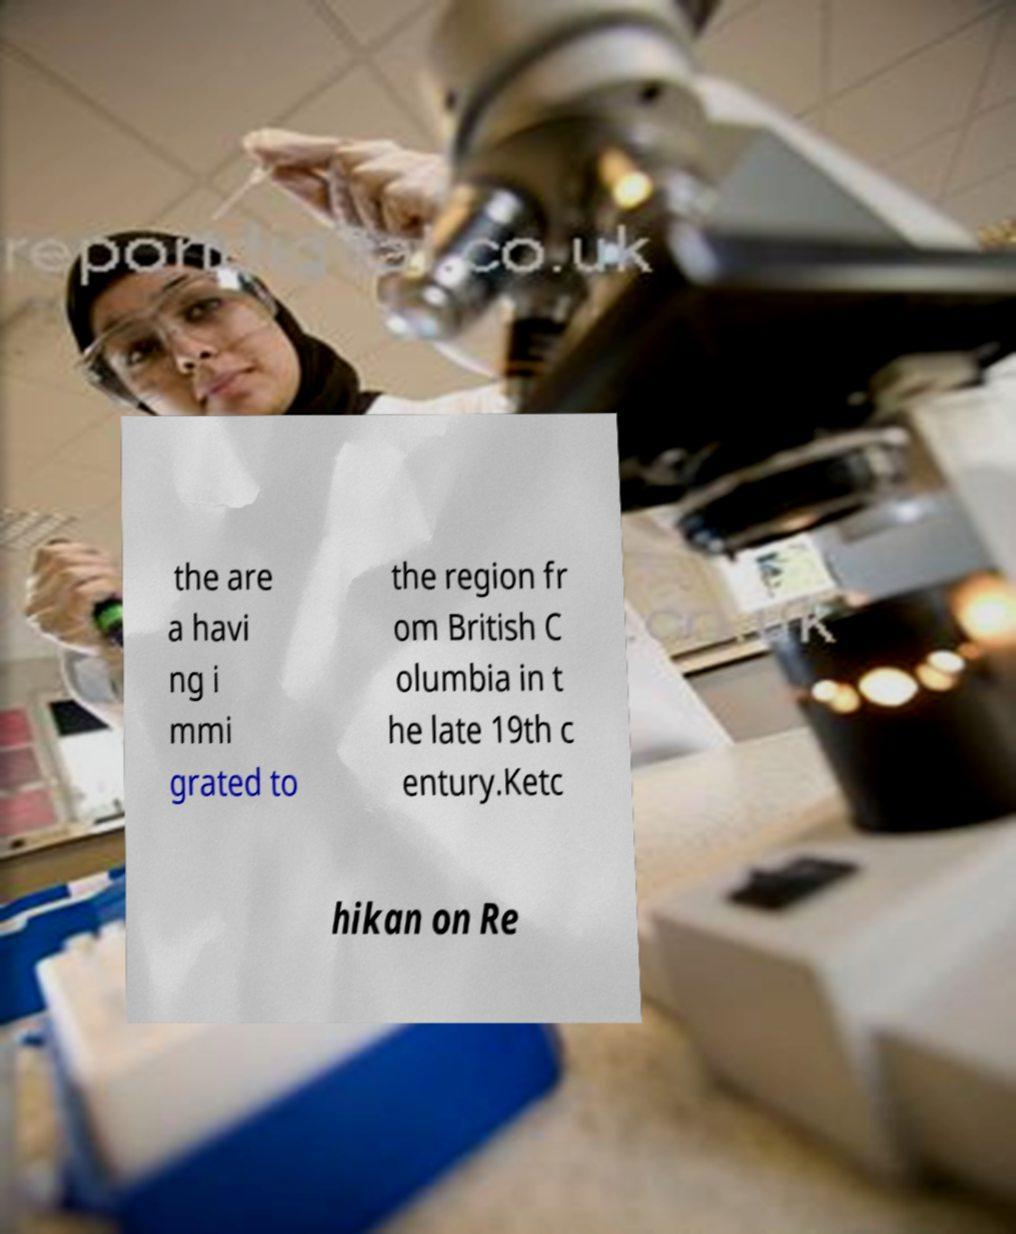Could you assist in decoding the text presented in this image and type it out clearly? the are a havi ng i mmi grated to the region fr om British C olumbia in t he late 19th c entury.Ketc hikan on Re 